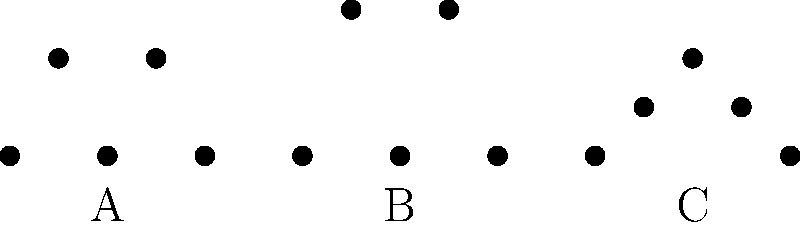Which silhouette represents the Fawn Leb, a traditional northern Thai fingernail dance characterized by graceful hand movements? To identify the Fawn Leb dance pose from the given silhouettes, let's analyze each one:

1. Silhouette A:
   - Shows a linear arrangement of figures
   - Alternating heights suggest a rigid, formal pose
   - This is likely the Khon, a classical Thai masked dance drama

2. Silhouette B:
   - Displays more varied heights and curves
   - The higher raised arms indicate intricate hand movements
   - This matches the description of Fawn Leb, known for its graceful hand gestures

3. Silhouette C:
   - Shows a more rounded, flowing shape
   - The figures seem to be in a circular formation
   - This likely represents the Ram Thai, a general term for traditional Thai dance

Given the description of Fawn Leb as a fingernail dance with graceful hand movements, silhouette B best matches this dance form. The raised arms and varied poses in this silhouette suggest the intricate finger and hand gestures characteristic of Fawn Leb.
Answer: B 